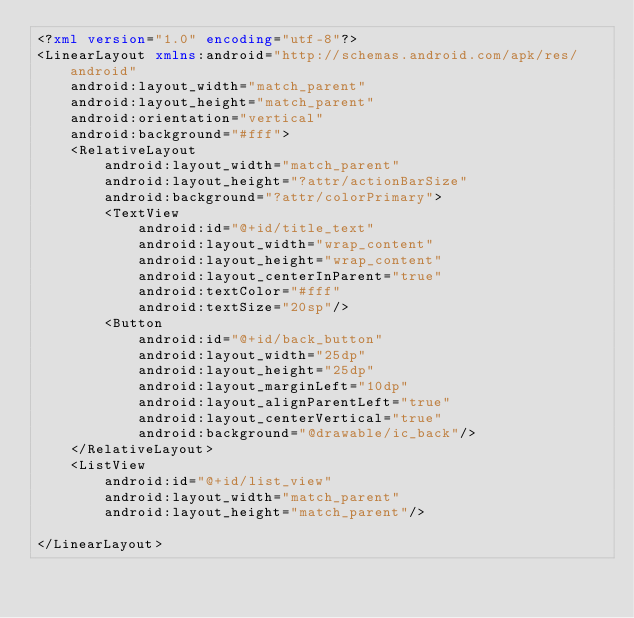Convert code to text. <code><loc_0><loc_0><loc_500><loc_500><_XML_><?xml version="1.0" encoding="utf-8"?>
<LinearLayout xmlns:android="http://schemas.android.com/apk/res/android"
    android:layout_width="match_parent"
    android:layout_height="match_parent"
    android:orientation="vertical"
    android:background="#fff">
    <RelativeLayout
        android:layout_width="match_parent"
        android:layout_height="?attr/actionBarSize"
        android:background="?attr/colorPrimary">
        <TextView
            android:id="@+id/title_text"
            android:layout_width="wrap_content"
            android:layout_height="wrap_content"
            android:layout_centerInParent="true"
            android:textColor="#fff"
            android:textSize="20sp"/>
        <Button
            android:id="@+id/back_button"
            android:layout_width="25dp"
            android:layout_height="25dp"
            android:layout_marginLeft="10dp"
            android:layout_alignParentLeft="true"
            android:layout_centerVertical="true"
            android:background="@drawable/ic_back"/>
    </RelativeLayout>
    <ListView
        android:id="@+id/list_view"
        android:layout_width="match_parent"
        android:layout_height="match_parent"/>

</LinearLayout></code> 